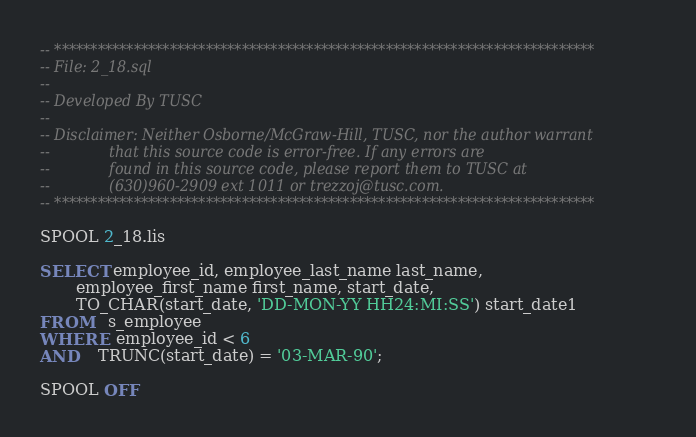Convert code to text. <code><loc_0><loc_0><loc_500><loc_500><_SQL_>-- ***************************************************************************
-- File: 2_18.sql
--
-- Developed By TUSC
--
-- Disclaimer: Neither Osborne/McGraw-Hill, TUSC, nor the author warrant
--             that this source code is error-free. If any errors are
--             found in this source code, please report them to TUSC at
--             (630)960-2909 ext 1011 or trezzoj@tusc.com.
-- ***************************************************************************

SPOOL 2_18.lis

SELECT employee_id, employee_last_name last_name, 
       employee_first_name first_name, start_date, 
       TO_CHAR(start_date, 'DD-MON-YY HH24:MI:SS') start_date1
FROM   s_employee
WHERE  employee_id < 6
AND    TRUNC(start_date) = '03-MAR-90';

SPOOL OFF
</code> 